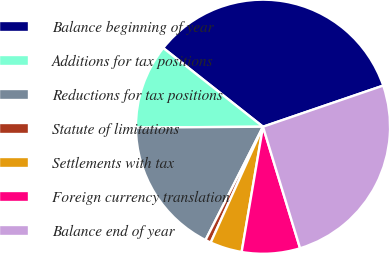<chart> <loc_0><loc_0><loc_500><loc_500><pie_chart><fcel>Balance beginning of year<fcel>Additions for tax positions<fcel>Reductions for tax positions<fcel>Statute of limitations<fcel>Settlements with tax<fcel>Foreign currency translation<fcel>Balance end of year<nl><fcel>34.12%<fcel>10.74%<fcel>17.42%<fcel>0.72%<fcel>4.06%<fcel>7.4%<fcel>25.53%<nl></chart> 